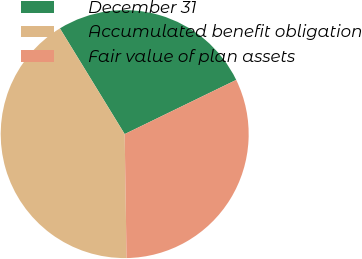<chart> <loc_0><loc_0><loc_500><loc_500><pie_chart><fcel>December 31<fcel>Accumulated benefit obligation<fcel>Fair value of plan assets<nl><fcel>26.55%<fcel>41.49%<fcel>31.96%<nl></chart> 